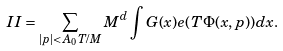Convert formula to latex. <formula><loc_0><loc_0><loc_500><loc_500>I I = \sum _ { | p | < A _ { 0 } T / M } M ^ { d } \int G ( x ) e ( T \Phi ( x , p ) ) d x .</formula> 